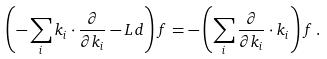<formula> <loc_0><loc_0><loc_500><loc_500>\left ( - \sum _ { i } k _ { i } \cdot \frac { \partial } { \partial k _ { i } } - L d \right ) f = - \left ( \sum _ { i } \frac { \partial } { \partial k _ { i } } \cdot k _ { i } \right ) f \, .</formula> 